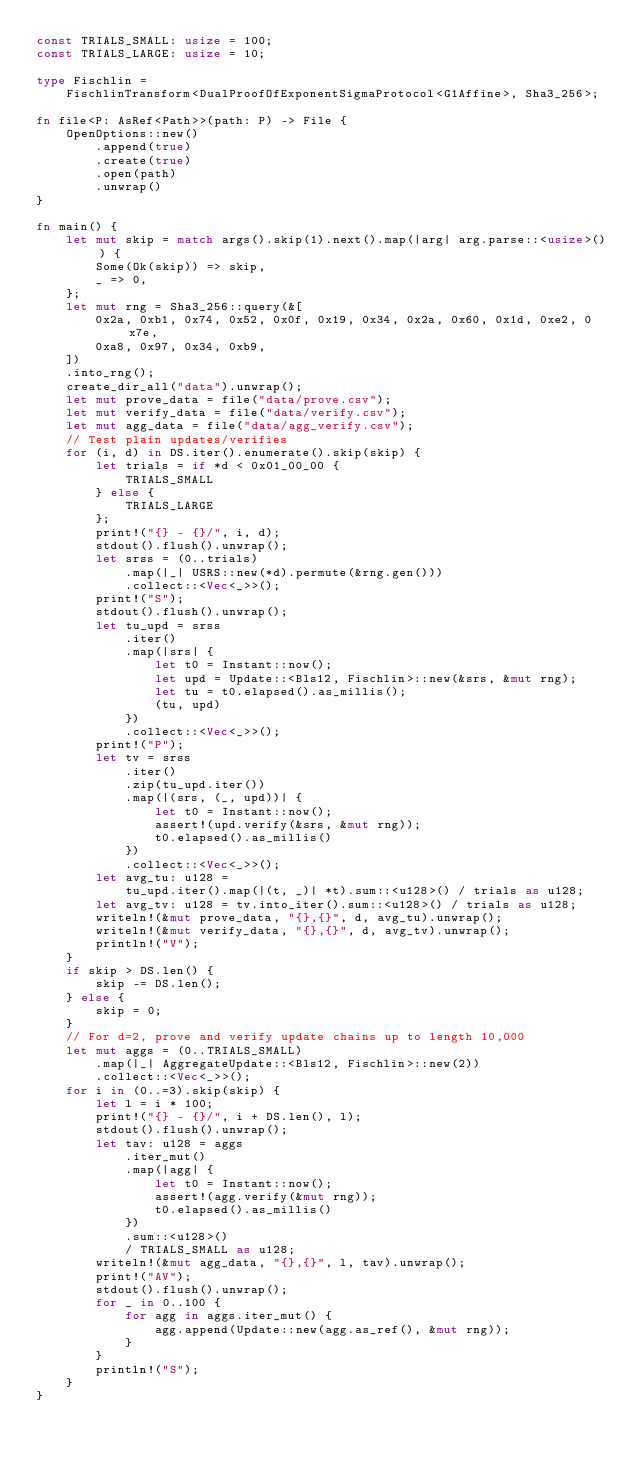<code> <loc_0><loc_0><loc_500><loc_500><_Rust_>const TRIALS_SMALL: usize = 100;
const TRIALS_LARGE: usize = 10;

type Fischlin =
    FischlinTransform<DualProofOfExponentSigmaProtocol<G1Affine>, Sha3_256>;

fn file<P: AsRef<Path>>(path: P) -> File {
    OpenOptions::new()
        .append(true)
        .create(true)
        .open(path)
        .unwrap()
}

fn main() {
    let mut skip = match args().skip(1).next().map(|arg| arg.parse::<usize>()) {
        Some(Ok(skip)) => skip,
        _ => 0,
    };
    let mut rng = Sha3_256::query(&[
        0x2a, 0xb1, 0x74, 0x52, 0x0f, 0x19, 0x34, 0x2a, 0x60, 0x1d, 0xe2, 0x7e,
        0xa8, 0x97, 0x34, 0xb9,
    ])
    .into_rng();
    create_dir_all("data").unwrap();
    let mut prove_data = file("data/prove.csv");
    let mut verify_data = file("data/verify.csv");
    let mut agg_data = file("data/agg_verify.csv");
    // Test plain updates/verifies
    for (i, d) in DS.iter().enumerate().skip(skip) {
        let trials = if *d < 0x01_00_00 {
            TRIALS_SMALL
        } else {
            TRIALS_LARGE
        };
        print!("{} - {}/", i, d);
        stdout().flush().unwrap();
        let srss = (0..trials)
            .map(|_| USRS::new(*d).permute(&rng.gen()))
            .collect::<Vec<_>>();
        print!("S");
        stdout().flush().unwrap();
        let tu_upd = srss
            .iter()
            .map(|srs| {
                let t0 = Instant::now();
                let upd = Update::<Bls12, Fischlin>::new(&srs, &mut rng);
                let tu = t0.elapsed().as_millis();
                (tu, upd)
            })
            .collect::<Vec<_>>();
        print!("P");
        let tv = srss
            .iter()
            .zip(tu_upd.iter())
            .map(|(srs, (_, upd))| {
                let t0 = Instant::now();
                assert!(upd.verify(&srs, &mut rng));
                t0.elapsed().as_millis()
            })
            .collect::<Vec<_>>();
        let avg_tu: u128 =
            tu_upd.iter().map(|(t, _)| *t).sum::<u128>() / trials as u128;
        let avg_tv: u128 = tv.into_iter().sum::<u128>() / trials as u128;
        writeln!(&mut prove_data, "{},{}", d, avg_tu).unwrap();
        writeln!(&mut verify_data, "{},{}", d, avg_tv).unwrap();
        println!("V");
    }
    if skip > DS.len() {
        skip -= DS.len();
    } else {
        skip = 0;
    }
    // For d=2, prove and verify update chains up to length 10,000
    let mut aggs = (0..TRIALS_SMALL)
        .map(|_| AggregateUpdate::<Bls12, Fischlin>::new(2))
        .collect::<Vec<_>>();
    for i in (0..=3).skip(skip) {
        let l = i * 100;
        print!("{} - {}/", i + DS.len(), l);
        stdout().flush().unwrap();
        let tav: u128 = aggs
            .iter_mut()
            .map(|agg| {
                let t0 = Instant::now();
                assert!(agg.verify(&mut rng));
                t0.elapsed().as_millis()
            })
            .sum::<u128>()
            / TRIALS_SMALL as u128;
        writeln!(&mut agg_data, "{},{}", l, tav).unwrap();
        print!("AV");
        stdout().flush().unwrap();
        for _ in 0..100 {
            for agg in aggs.iter_mut() {
                agg.append(Update::new(agg.as_ref(), &mut rng));
            }
        }
        println!("S");
    }
}
</code> 